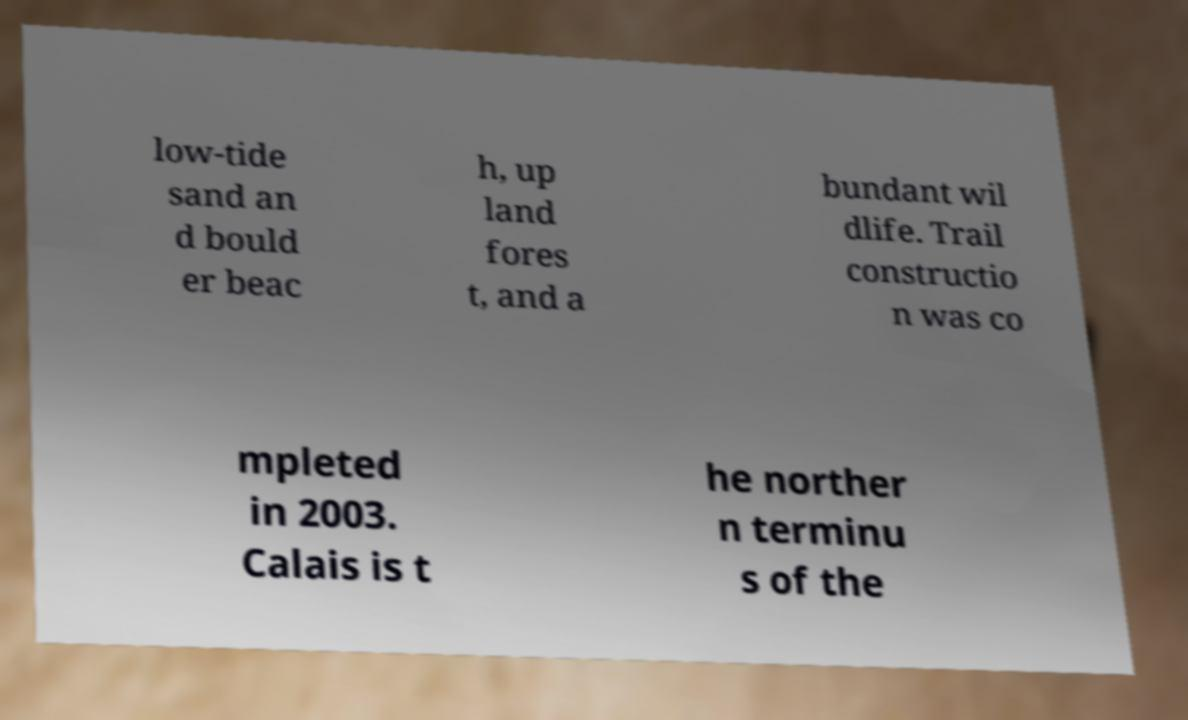For documentation purposes, I need the text within this image transcribed. Could you provide that? low-tide sand an d bould er beac h, up land fores t, and a bundant wil dlife. Trail constructio n was co mpleted in 2003. Calais is t he norther n terminu s of the 